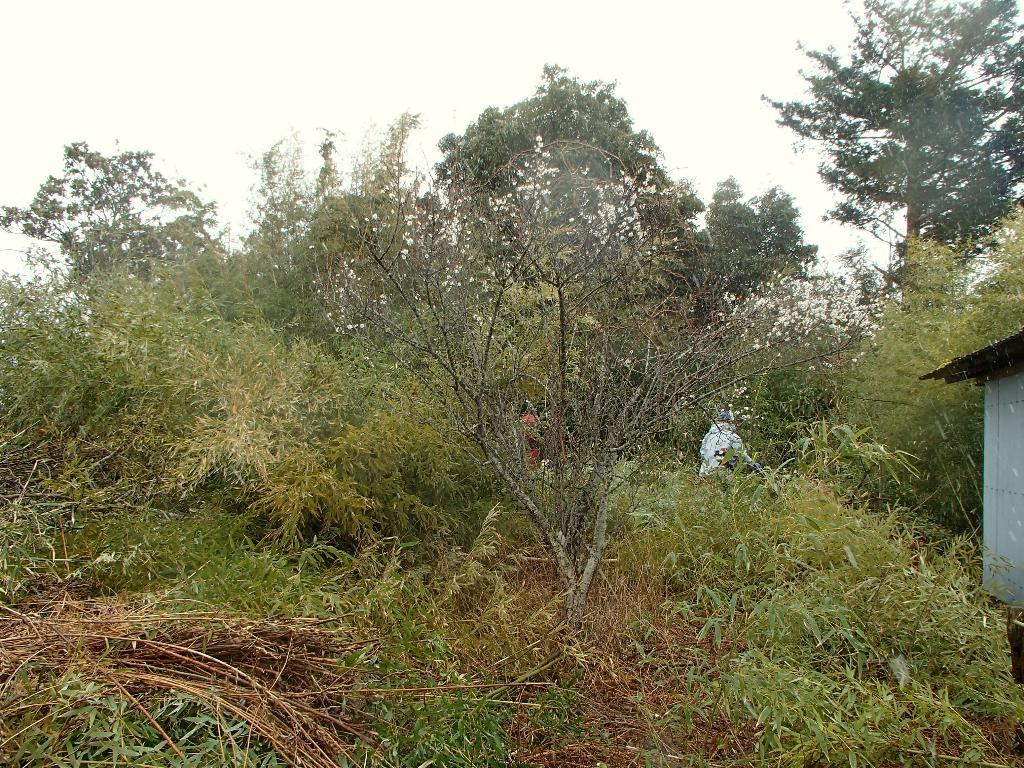What type of natural elements can be seen in the image? There are many trees and plants in the image. What part of the natural environment is visible in the image? The sky is visible in the image. What type of structure can be seen at the right side of the image? There is a shed at the right side of the image. How many people are present in the image? There are few people in the image. Where is the toothbrush located in the image? There is no toothbrush present in the image. What type of iron is being used by the mom in the image? There is no mom or iron present in the image. 